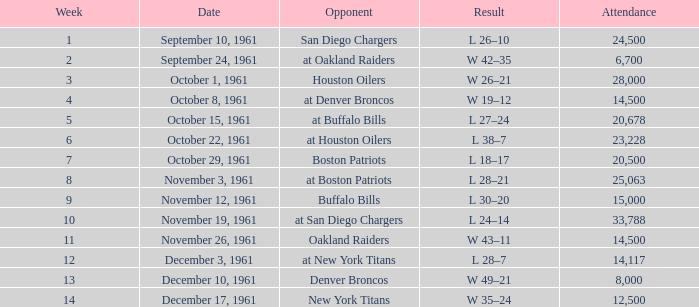What is the maximum attendance for weeks after 2 on october 29, 1961? 20500.0. 